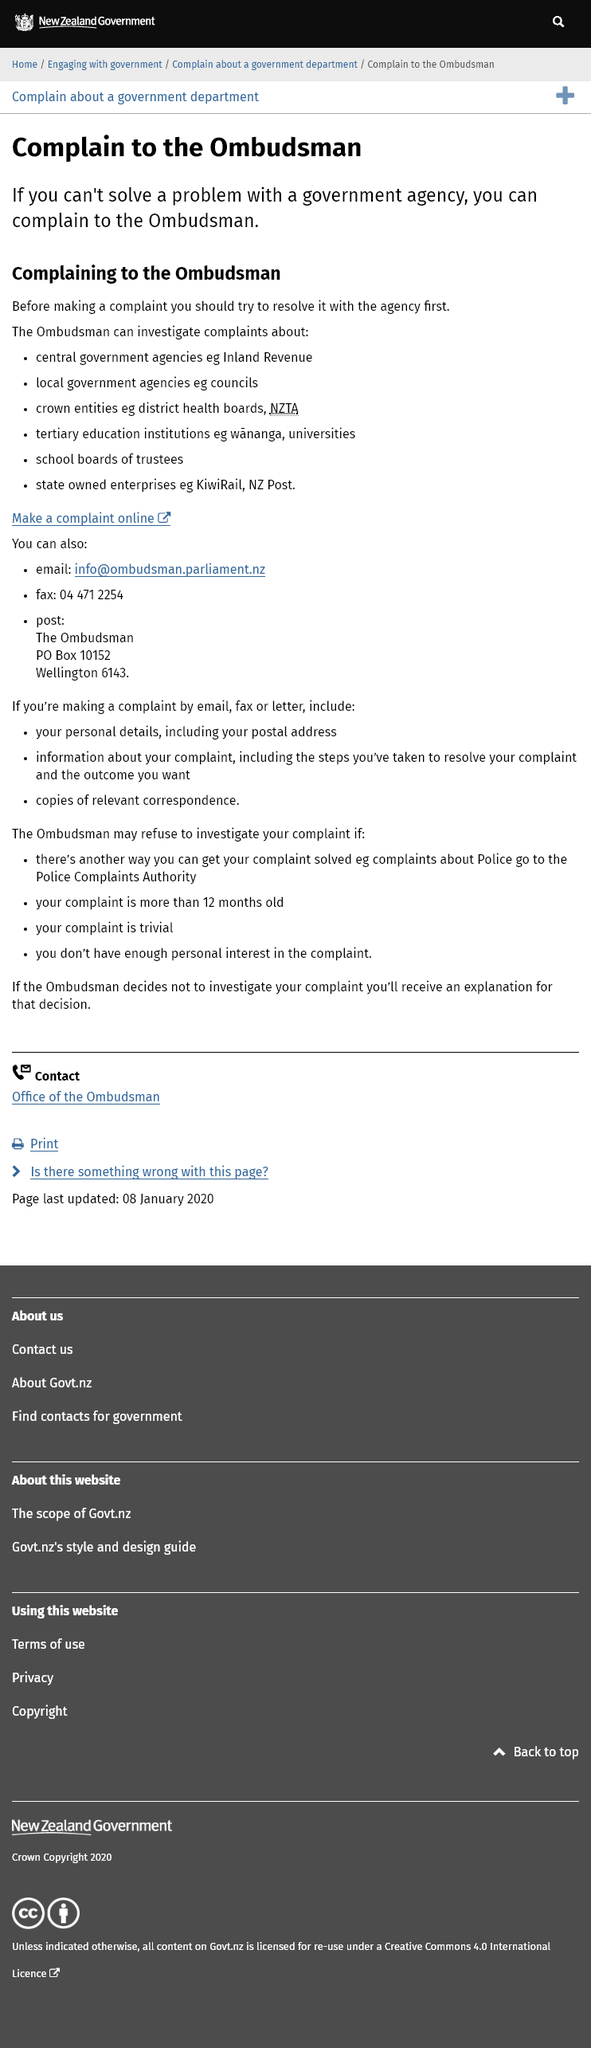Outline some significant characteristics in this image. It is advisable to attempt to resolve the issue with the agency before making a complaint to the Ombudsman. The Ombudsman has the authority to investigate complaints about the Inland Revenue. The Ombudsman has the authority to investigate complaints about KiwiRail. 